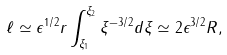Convert formula to latex. <formula><loc_0><loc_0><loc_500><loc_500>\ell \simeq \epsilon ^ { 1 / 2 } r \int _ { \xi _ { 1 } } ^ { \xi _ { 2 } } \xi ^ { - 3 / 2 } d \xi \simeq 2 \epsilon ^ { 3 / 2 } R ,</formula> 